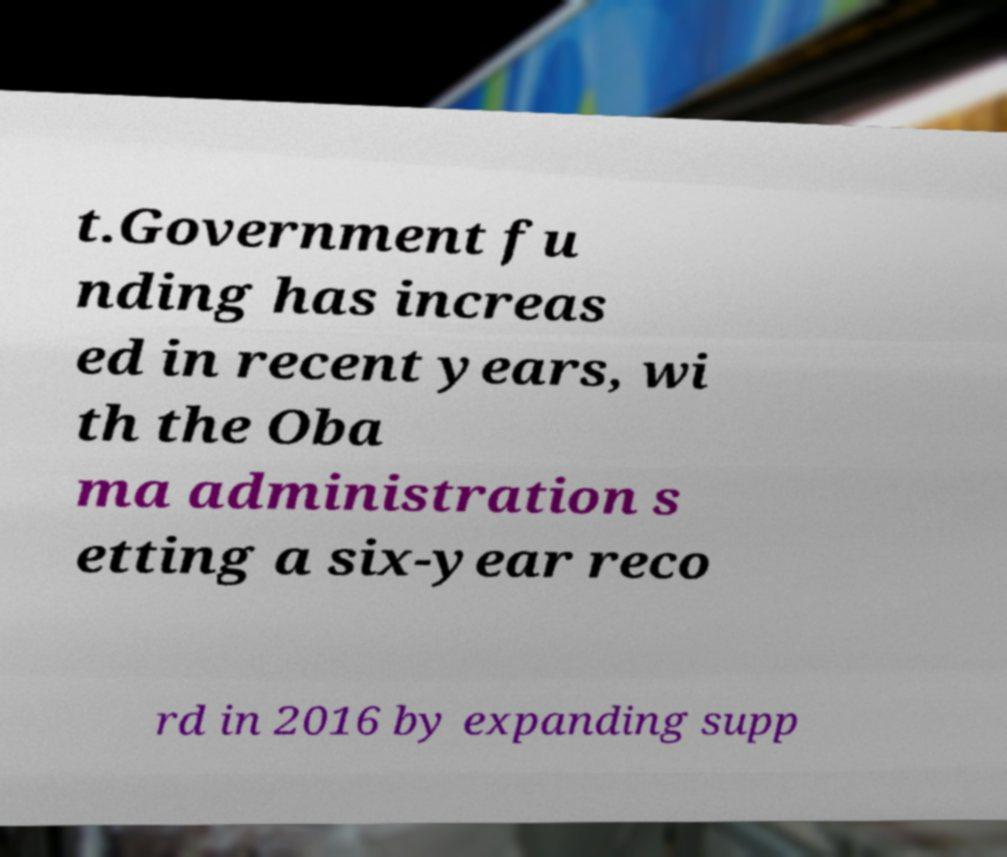I need the written content from this picture converted into text. Can you do that? t.Government fu nding has increas ed in recent years, wi th the Oba ma administration s etting a six-year reco rd in 2016 by expanding supp 